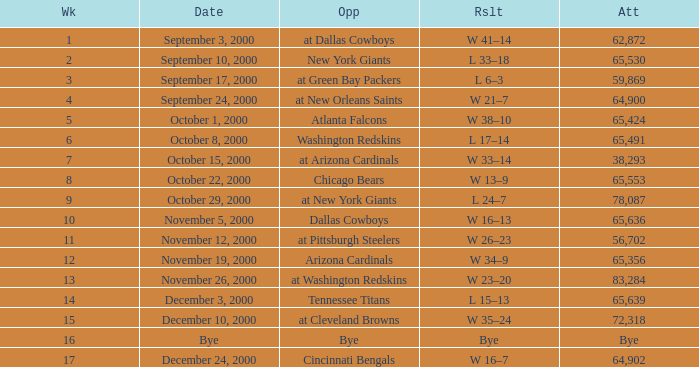What was the attendance when the Cincinnati Bengals were the opponents? 64902.0. 